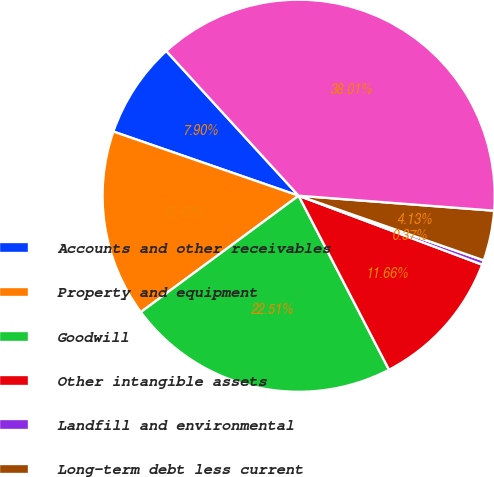Convert chart to OTSL. <chart><loc_0><loc_0><loc_500><loc_500><pie_chart><fcel>Accounts and other receivables<fcel>Property and equipment<fcel>Goodwill<fcel>Other intangible assets<fcel>Landfill and environmental<fcel>Long-term debt less current<fcel>Total purchase price<nl><fcel>7.9%<fcel>15.42%<fcel>22.51%<fcel>11.66%<fcel>0.37%<fcel>4.13%<fcel>38.01%<nl></chart> 